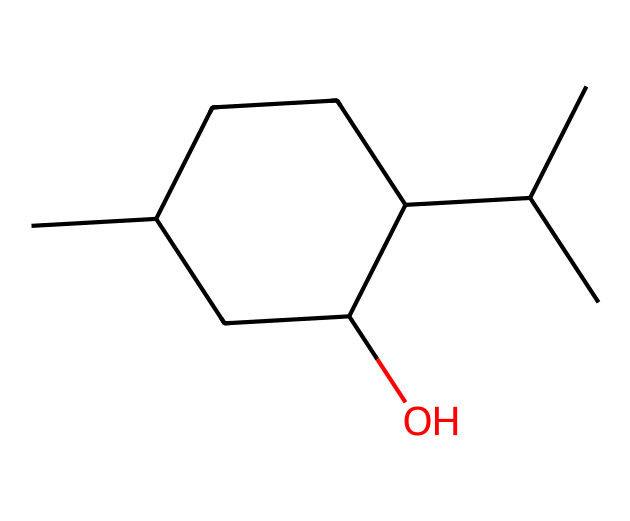how many carbon atoms are in this structure? The chemical structure can be analyzed by counting all carbon atoms represented in the SMILES notation. The representation consists of two "CC" at the start, followed by a cycloalkane with five additional carbons in the ring. Thus, the total count is 10 carbon atoms.
Answer: 10 what is the functional group present in menthol? The Smith notation indicates the presence of a hydroxyl (-OH) group. In the cycloalkane structure, this group is denoted by "C(O)", suggesting that menthol has an alcohol functional group.
Answer: alcohol how many rings are present in this structure? The SMILES representation indicates the use of "C1" and "C1" to denote the start and end of a cycloalkane ring. Therefore, it shows one cyclic structure.
Answer: 1 which type of cycloalkane is represented here? By examining the structure, including the single-ring formation and the saturation of carbon atoms, it is clear that this is a cyclohexane derivative due to the presence of six carbon atoms in a ring formation along with branches.
Answer: cyclohexane is menthol a saturated or unsaturated compound? The presence of single bonds between carbon atoms indicates that there are no double or triple bonds, leading to the conclusion that menthol is a saturated compound.
Answer: saturated how many hydrogen atoms are attached to the structure? The saturation of the cycloalkane, along with the saturation rules for aliphatic compounds, allows us to deduce the total number of hydrogen atoms. Each carbon typically bonds with enough hydrogens to have four total bonds. Counting yields 22 hydrogen atoms for the structure.
Answer: 22 what role do cycloalkanes like menthol play in medical supplies? Cycloalkanes like menthol can have medicinal properties, often used in formulations to provide soothing effects or as a topical analgesic in medical supplies.
Answer: soothing agents 